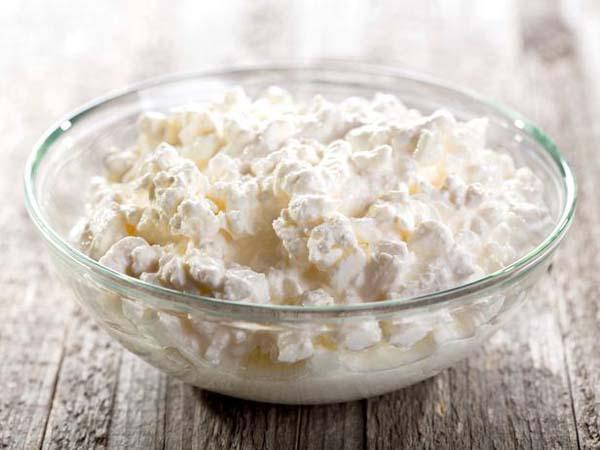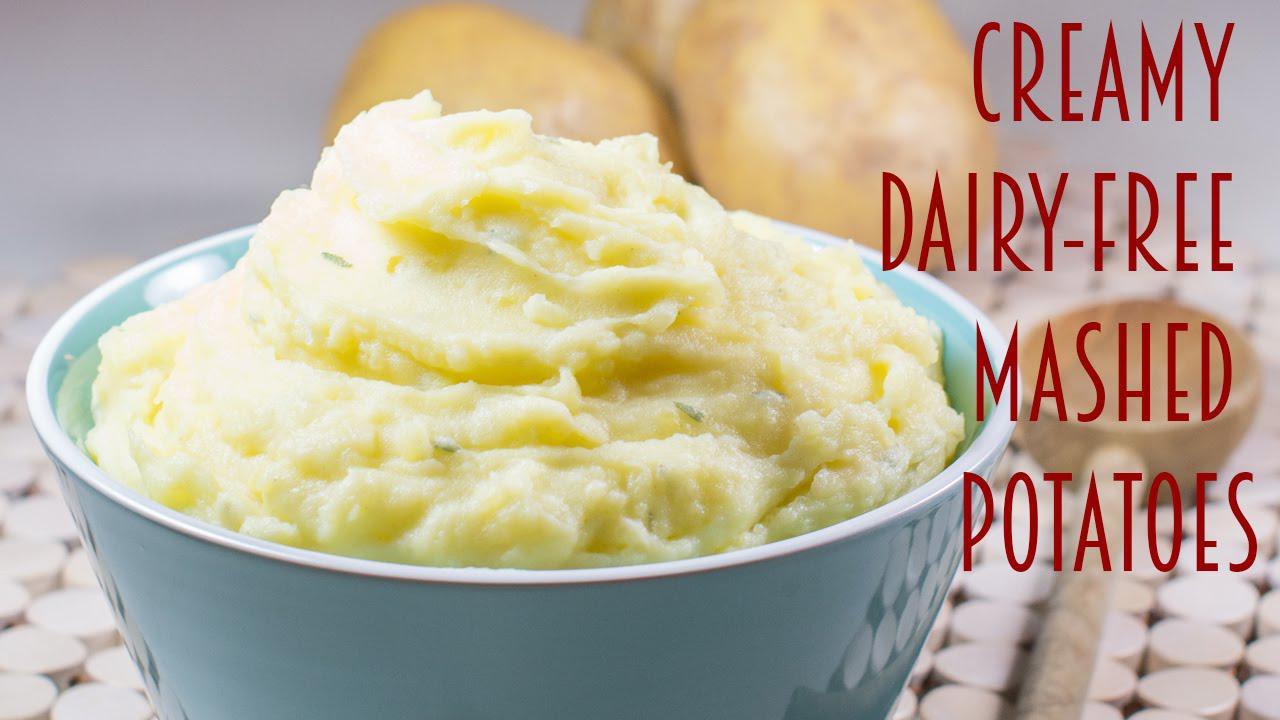The first image is the image on the left, the second image is the image on the right. Given the left and right images, does the statement "The mashed potatoes in the right image are inside of a white container." hold true? Answer yes or no. No. The first image is the image on the left, the second image is the image on the right. Examine the images to the left and right. Is the description "Some of the mashed potatoes are in a green bowl sitting on top of a striped tablecloth." accurate? Answer yes or no. No. 